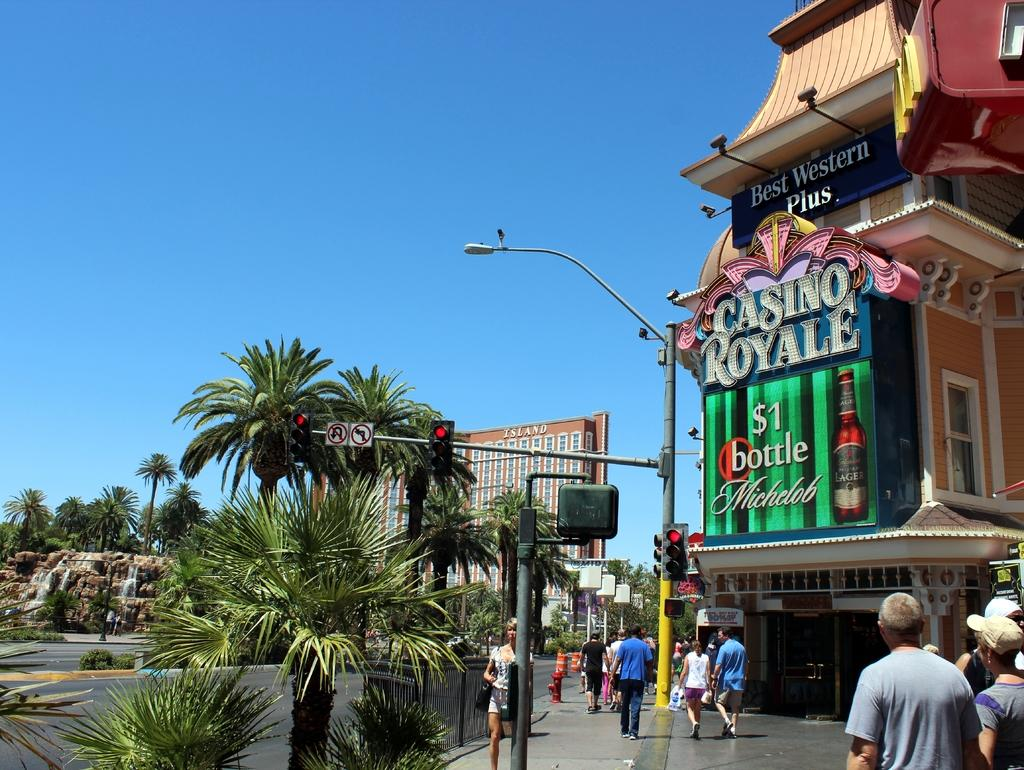Where was the image taken? The image was clicked outside. What can be seen in the middle of the image? There are buildings and trees in the middle of the image. What is happening at the bottom of the image? There are people walking at the bottom of the image. What is visible at the top of the image? The sky is visible at the top of the image. What type of button can be seen on the mind of the person in the image? There is no person or button present in the image; it features buildings, trees, and people walking. How does the image start the process of understanding the concept of time? The image itself does not start any process or convey any concept; it is a static representation of a scene. 